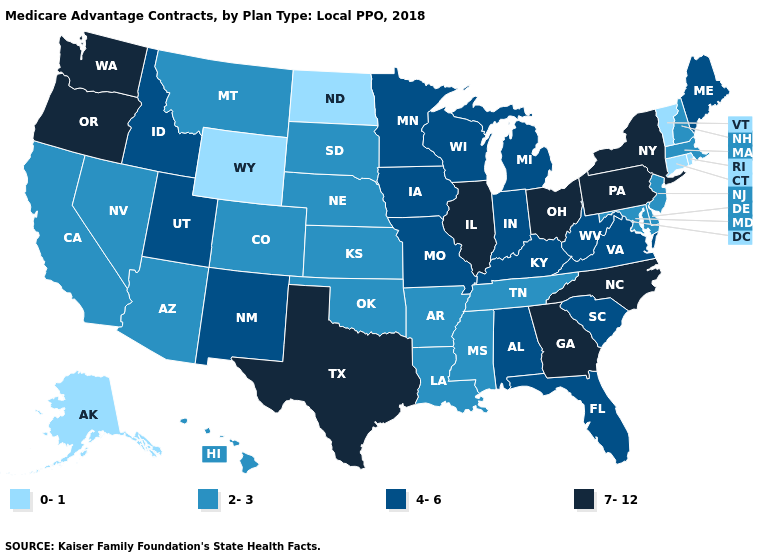Which states have the lowest value in the West?
Answer briefly. Alaska, Wyoming. Is the legend a continuous bar?
Keep it brief. No. Does North Dakota have the lowest value in the MidWest?
Short answer required. Yes. Does Colorado have a lower value than Oregon?
Concise answer only. Yes. Name the states that have a value in the range 4-6?
Keep it brief. Alabama, Florida, Iowa, Idaho, Indiana, Kentucky, Maine, Michigan, Minnesota, Missouri, New Mexico, South Carolina, Utah, Virginia, Wisconsin, West Virginia. What is the value of Massachusetts?
Answer briefly. 2-3. What is the value of Kentucky?
Give a very brief answer. 4-6. What is the lowest value in the USA?
Be succinct. 0-1. Name the states that have a value in the range 2-3?
Give a very brief answer. Arkansas, Arizona, California, Colorado, Delaware, Hawaii, Kansas, Louisiana, Massachusetts, Maryland, Mississippi, Montana, Nebraska, New Hampshire, New Jersey, Nevada, Oklahoma, South Dakota, Tennessee. Which states have the lowest value in the USA?
Concise answer only. Alaska, Connecticut, North Dakota, Rhode Island, Vermont, Wyoming. Is the legend a continuous bar?
Be succinct. No. What is the value of Michigan?
Short answer required. 4-6. What is the lowest value in states that border Texas?
Quick response, please. 2-3. Among the states that border Massachusetts , which have the highest value?
Quick response, please. New York. Which states have the lowest value in the MidWest?
Concise answer only. North Dakota. 